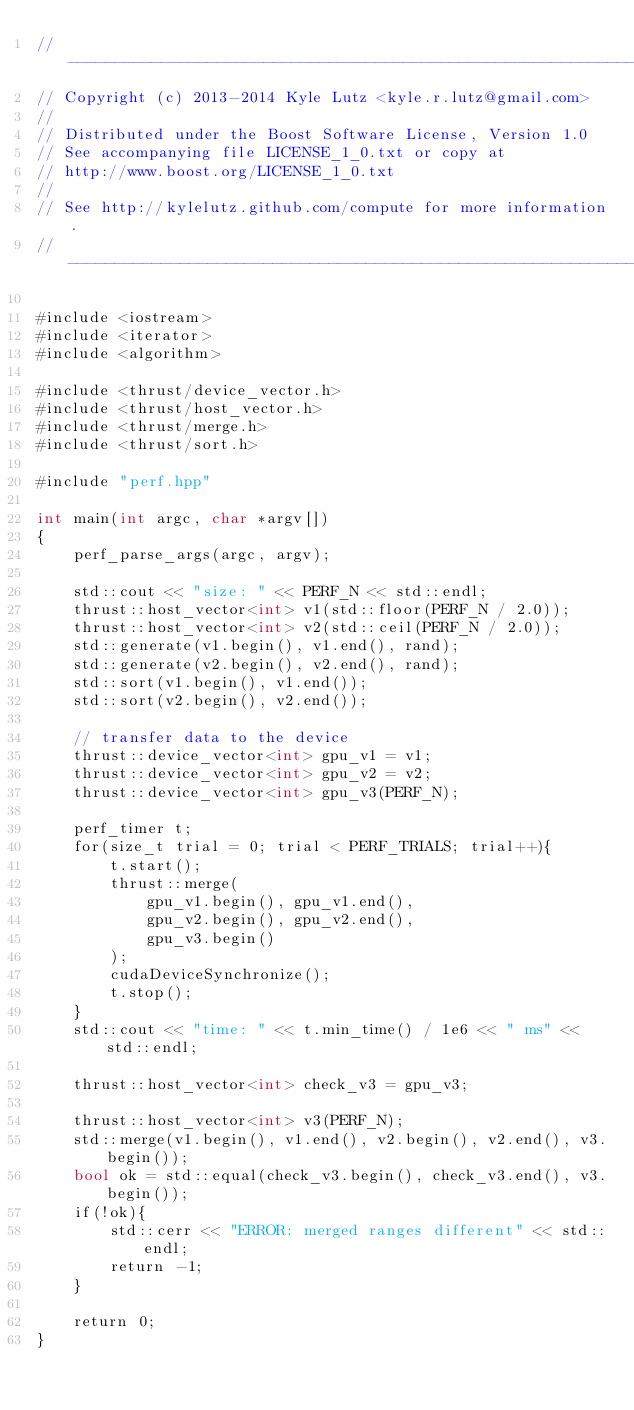<code> <loc_0><loc_0><loc_500><loc_500><_Cuda_>//---------------------------------------------------------------------------//
// Copyright (c) 2013-2014 Kyle Lutz <kyle.r.lutz@gmail.com>
//
// Distributed under the Boost Software License, Version 1.0
// See accompanying file LICENSE_1_0.txt or copy at
// http://www.boost.org/LICENSE_1_0.txt
//
// See http://kylelutz.github.com/compute for more information.
//---------------------------------------------------------------------------//

#include <iostream>
#include <iterator>
#include <algorithm>

#include <thrust/device_vector.h>
#include <thrust/host_vector.h>
#include <thrust/merge.h>
#include <thrust/sort.h>

#include "perf.hpp"

int main(int argc, char *argv[])
{
    perf_parse_args(argc, argv);

    std::cout << "size: " << PERF_N << std::endl;
    thrust::host_vector<int> v1(std::floor(PERF_N / 2.0));
    thrust::host_vector<int> v2(std::ceil(PERF_N / 2.0));
    std::generate(v1.begin(), v1.end(), rand);
    std::generate(v2.begin(), v2.end(), rand);
    std::sort(v1.begin(), v1.end());
    std::sort(v2.begin(), v2.end());

    // transfer data to the device
    thrust::device_vector<int> gpu_v1 = v1;
    thrust::device_vector<int> gpu_v2 = v2;
    thrust::device_vector<int> gpu_v3(PERF_N);

    perf_timer t;
    for(size_t trial = 0; trial < PERF_TRIALS; trial++){
        t.start();
        thrust::merge(
            gpu_v1.begin(), gpu_v1.end(),
            gpu_v2.begin(), gpu_v2.end(),
            gpu_v3.begin()
        );
        cudaDeviceSynchronize();
        t.stop();
    }
    std::cout << "time: " << t.min_time() / 1e6 << " ms" << std::endl;

    thrust::host_vector<int> check_v3 = gpu_v3;

    thrust::host_vector<int> v3(PERF_N);
    std::merge(v1.begin(), v1.end(), v2.begin(), v2.end(), v3.begin());
    bool ok = std::equal(check_v3.begin(), check_v3.end(), v3.begin());
    if(!ok){
        std::cerr << "ERROR: merged ranges different" << std::endl;
        return -1;
    }

    return 0;
}
</code> 